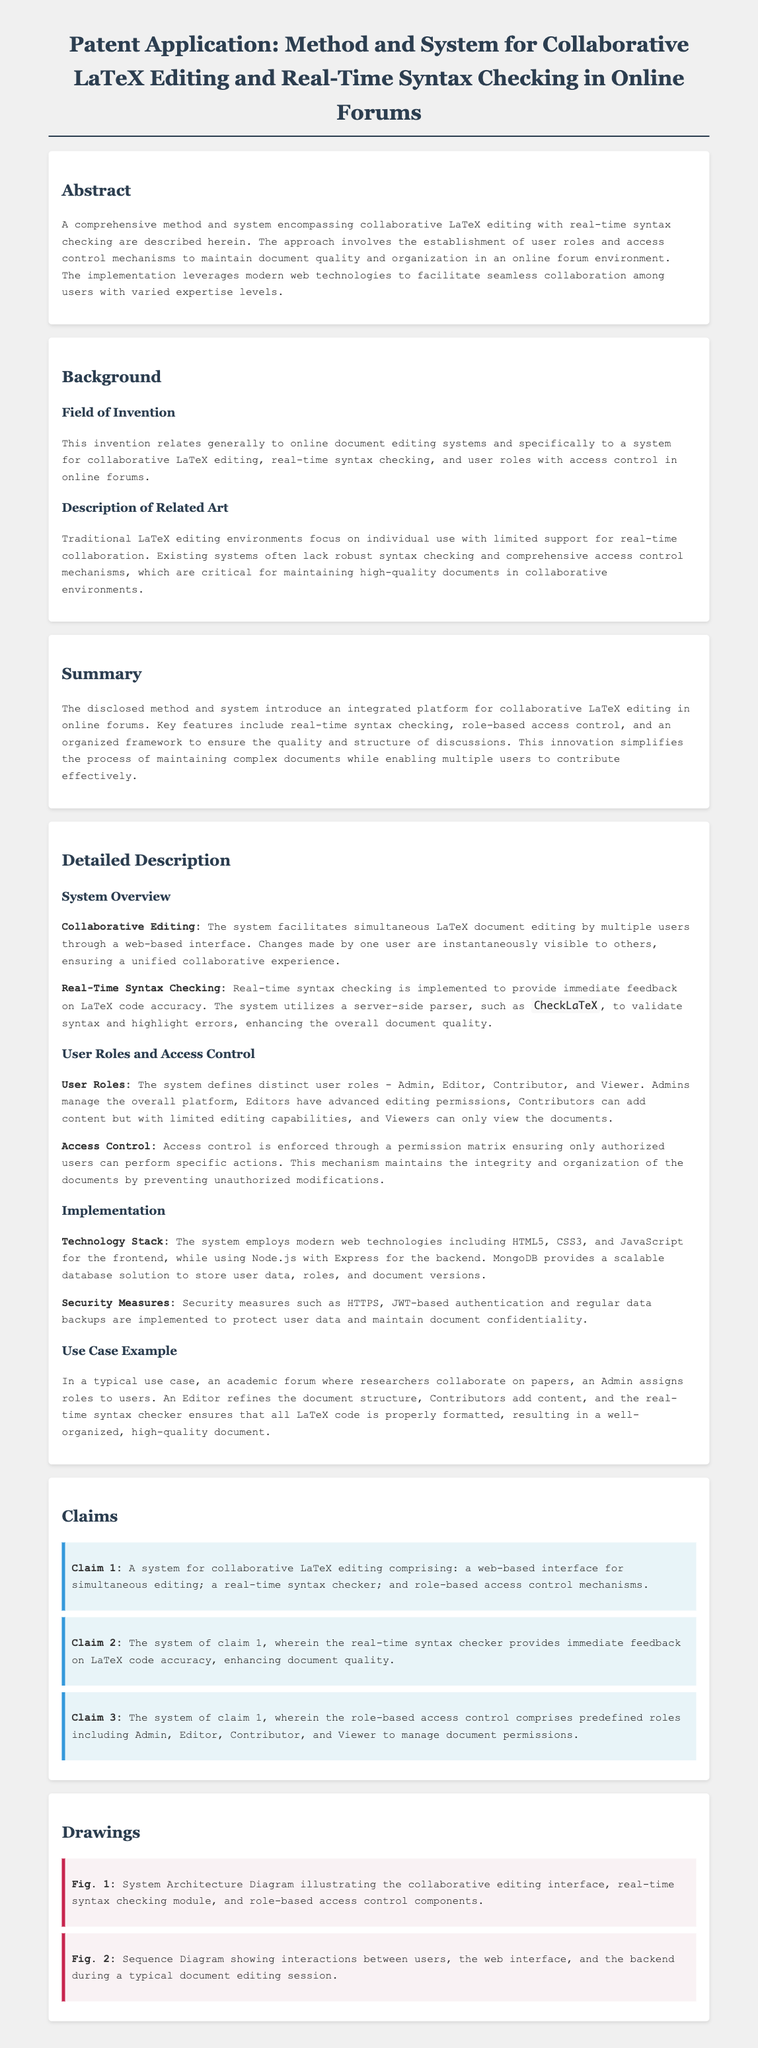What is the focus of the invention? The focus of the invention is described in the field of invention section, specifically to a system for collaborative LaTeX editing, real-time syntax checking, and user roles with access control in online forums.
Answer: collaborative LaTeX editing What roles are defined in the system? The user roles are defined in the user roles and access control section, which includes Admin, Editor, Contributor, and Viewer.
Answer: Admin, Editor, Contributor, Viewer What is the technology stack mentioned for the implementation? The technology stack is listed in the implementation section, detailing the frontend and backend technologies used.
Answer: HTML5, CSS3, JavaScript, Node.js, Express, MongoDB What is the immediate feedback mechanism employed in the system? The mechanism for providing immediate feedback is detailed in the real-time syntax checking section, focusing on LaTeX code accuracy.
Answer: real-time syntax checker How many claims are presented in the document? The number of claims is evident in the claims section, where each claim is listed individually.
Answer: 3 What is the purpose of the real-time syntax checker? The purpose is explicitly mentioned in the detailed description of the system, stating that it enhances document quality.
Answer: enhance document quality What does HTTPS serve in the security measures? HTTPS is mentioned in the security measures section as a security protocol for protecting user data.
Answer: protect user data What does Figure 1 illustrate? The figure is elaborated in the drawings section, specifically indicating the system components.
Answer: System Architecture Diagram 